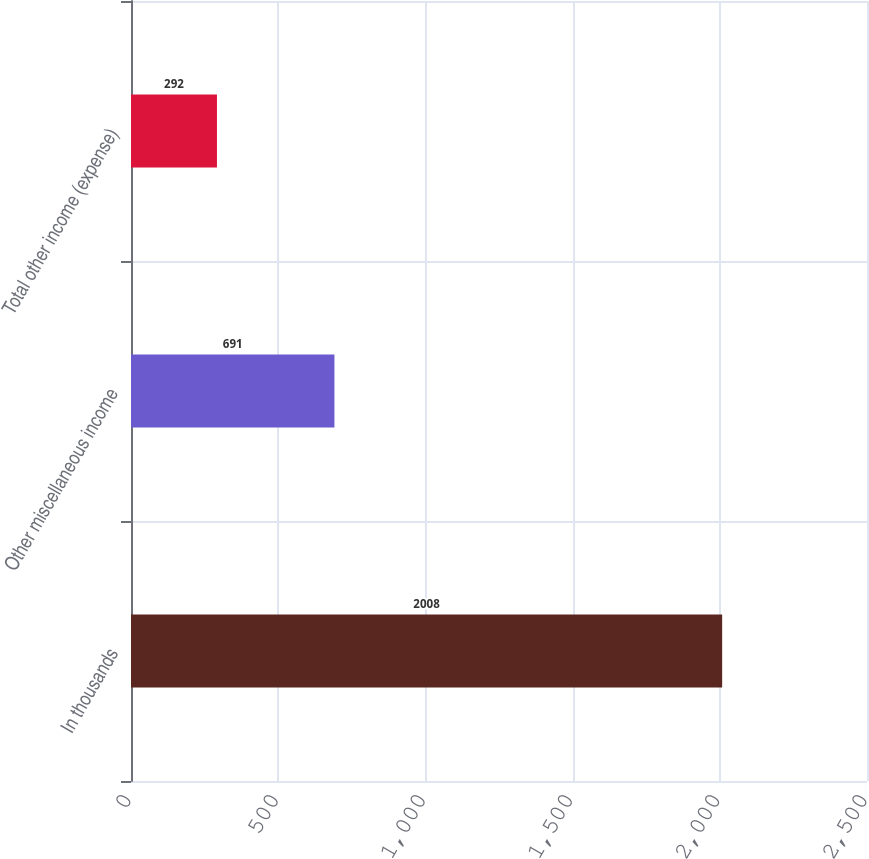Convert chart to OTSL. <chart><loc_0><loc_0><loc_500><loc_500><bar_chart><fcel>In thousands<fcel>Other miscellaneous income<fcel>Total other income (expense)<nl><fcel>2008<fcel>691<fcel>292<nl></chart> 